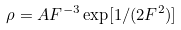<formula> <loc_0><loc_0><loc_500><loc_500>\rho = A F ^ { - 3 } \exp [ 1 / ( 2 F ^ { 2 } ) ]</formula> 